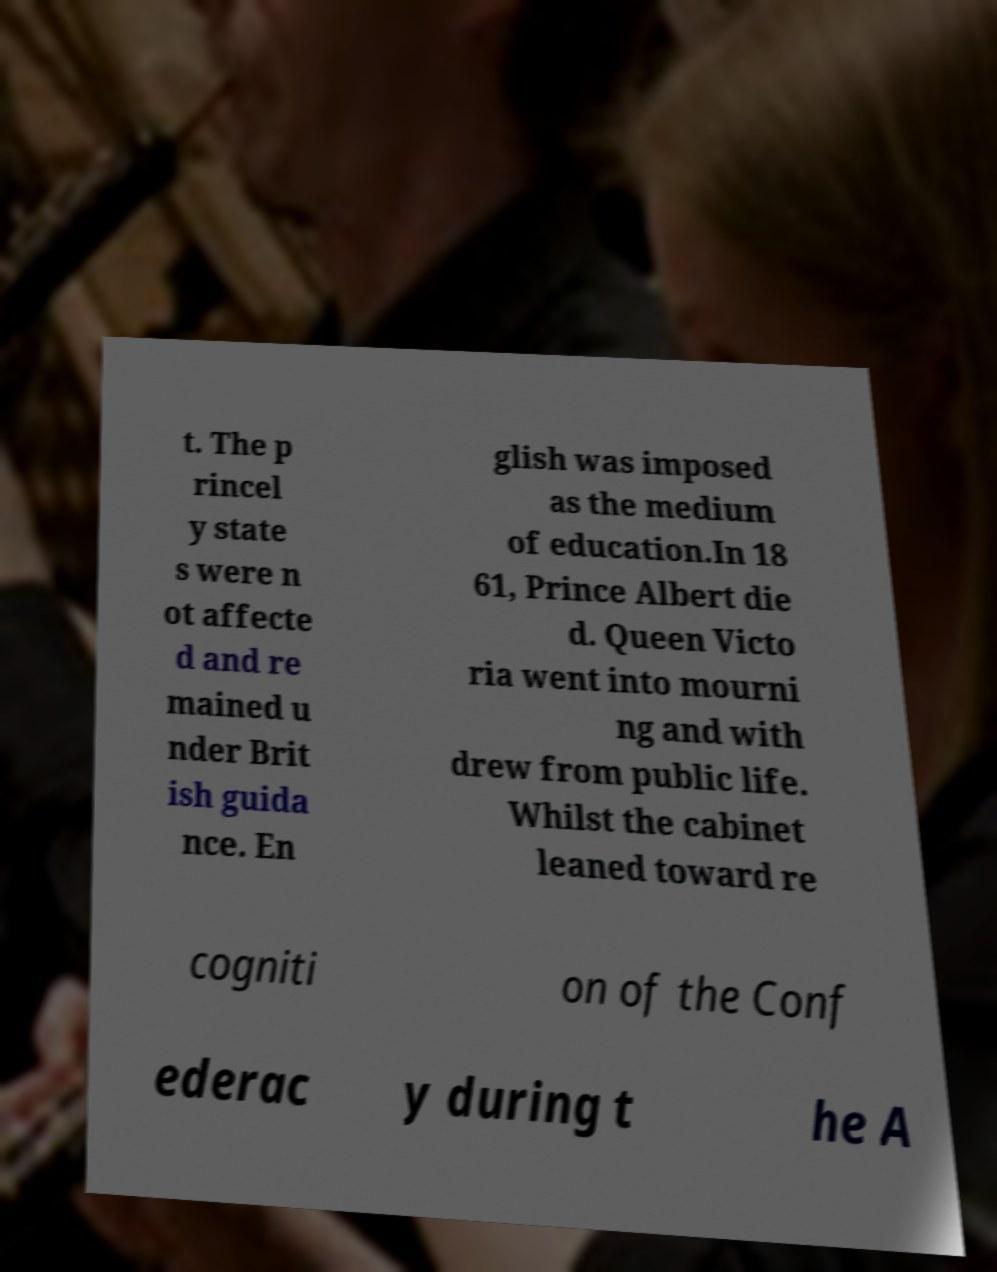Can you read and provide the text displayed in the image?This photo seems to have some interesting text. Can you extract and type it out for me? t. The p rincel y state s were n ot affecte d and re mained u nder Brit ish guida nce. En glish was imposed as the medium of education.In 18 61, Prince Albert die d. Queen Victo ria went into mourni ng and with drew from public life. Whilst the cabinet leaned toward re cogniti on of the Conf ederac y during t he A 